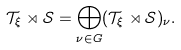Convert formula to latex. <formula><loc_0><loc_0><loc_500><loc_500>\mathcal { T } _ { \xi } \rtimes \mathcal { S } = \bigoplus _ { \nu \in G } ( \mathcal { T } _ { \xi } \rtimes \mathcal { S } ) _ { \nu } .</formula> 